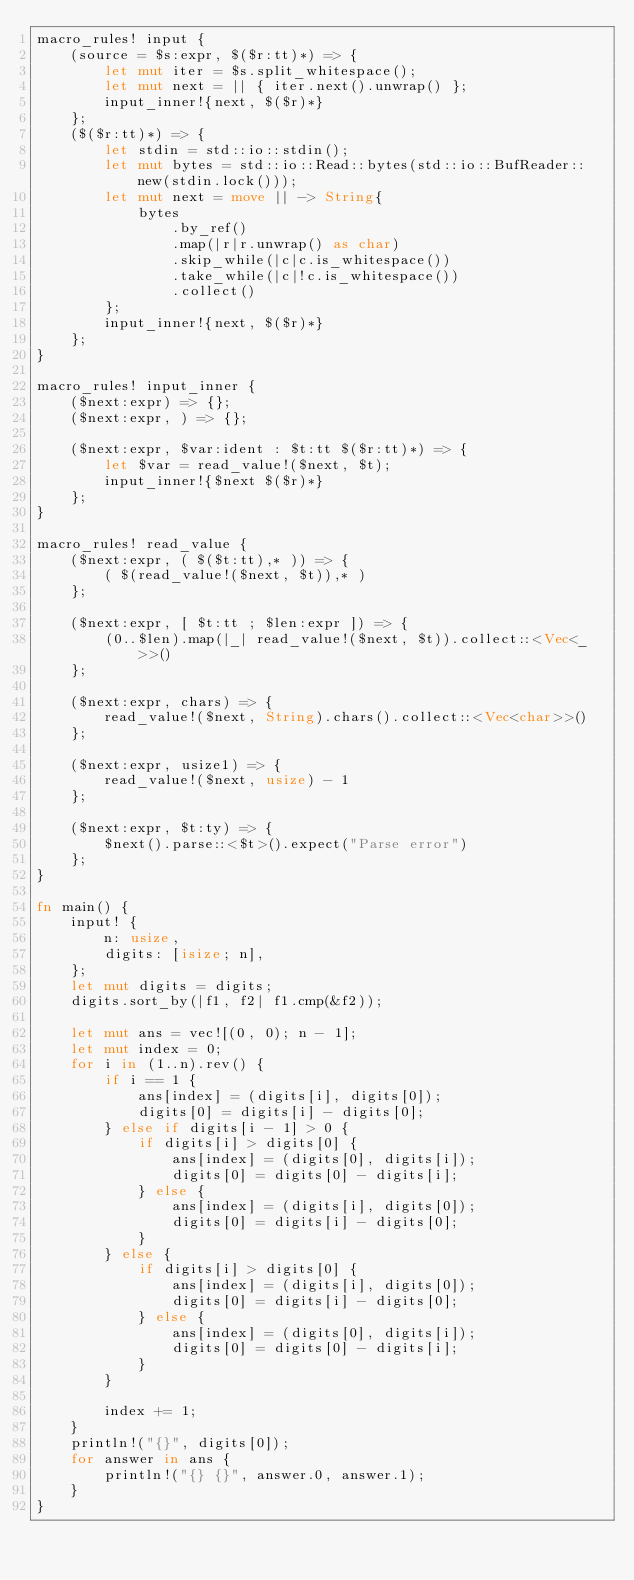Convert code to text. <code><loc_0><loc_0><loc_500><loc_500><_Rust_>macro_rules! input {
    (source = $s:expr, $($r:tt)*) => {
        let mut iter = $s.split_whitespace();
        let mut next = || { iter.next().unwrap() };
        input_inner!{next, $($r)*}
    };
    ($($r:tt)*) => {
        let stdin = std::io::stdin();
        let mut bytes = std::io::Read::bytes(std::io::BufReader::new(stdin.lock()));
        let mut next = move || -> String{
            bytes
                .by_ref()
                .map(|r|r.unwrap() as char)
                .skip_while(|c|c.is_whitespace())
                .take_while(|c|!c.is_whitespace())
                .collect()
        };
        input_inner!{next, $($r)*}
    };
}

macro_rules! input_inner {
    ($next:expr) => {};
    ($next:expr, ) => {};

    ($next:expr, $var:ident : $t:tt $($r:tt)*) => {
        let $var = read_value!($next, $t);
        input_inner!{$next $($r)*}
    };
}

macro_rules! read_value {
    ($next:expr, ( $($t:tt),* )) => {
        ( $(read_value!($next, $t)),* )
    };

    ($next:expr, [ $t:tt ; $len:expr ]) => {
        (0..$len).map(|_| read_value!($next, $t)).collect::<Vec<_>>()
    };

    ($next:expr, chars) => {
        read_value!($next, String).chars().collect::<Vec<char>>()
    };

    ($next:expr, usize1) => {
        read_value!($next, usize) - 1
    };

    ($next:expr, $t:ty) => {
        $next().parse::<$t>().expect("Parse error")
    };
}

fn main() {
    input! {
        n: usize,
        digits: [isize; n],
    };
    let mut digits = digits;
    digits.sort_by(|f1, f2| f1.cmp(&f2));

    let mut ans = vec![(0, 0); n - 1];
    let mut index = 0;
    for i in (1..n).rev() {
        if i == 1 {
            ans[index] = (digits[i], digits[0]);
            digits[0] = digits[i] - digits[0];
        } else if digits[i - 1] > 0 {
            if digits[i] > digits[0] {
                ans[index] = (digits[0], digits[i]);
                digits[0] = digits[0] - digits[i];
            } else {
                ans[index] = (digits[i], digits[0]);
                digits[0] = digits[i] - digits[0];
            }
        } else {
            if digits[i] > digits[0] {
                ans[index] = (digits[i], digits[0]);
                digits[0] = digits[i] - digits[0];
            } else {
                ans[index] = (digits[0], digits[i]);
                digits[0] = digits[0] - digits[i];
            }
        }

        index += 1;
    }
    println!("{}", digits[0]);
    for answer in ans {
        println!("{} {}", answer.0, answer.1);
    }
}
</code> 